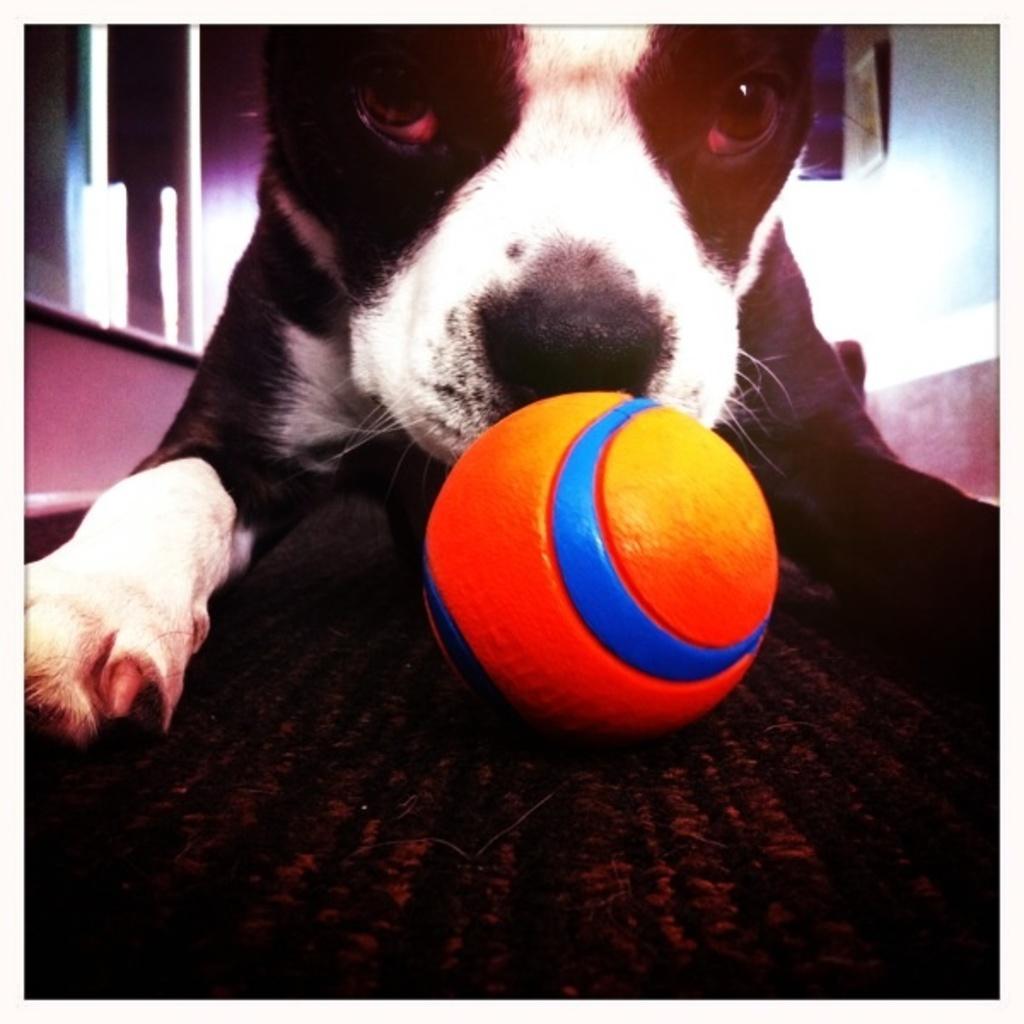In one or two sentences, can you explain what this image depicts? As we can see in the image in the front there is a black color dog and a ball. In the background there is a wall. 